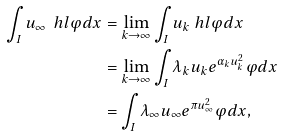Convert formula to latex. <formula><loc_0><loc_0><loc_500><loc_500>\int _ { I } u _ { \infty } \ h l \varphi d x & = \lim _ { k \to \infty } \int _ { I } u _ { k } \ h l \varphi d x \\ & = \lim _ { k \to \infty } \int _ { I } \lambda _ { k } u _ { k } e ^ { \alpha _ { k } u _ { k } ^ { 2 } } \varphi d x \\ & = \int _ { I } \lambda _ { \infty } u _ { \infty } e ^ { \pi u _ { \infty } ^ { 2 } } \varphi d x ,</formula> 